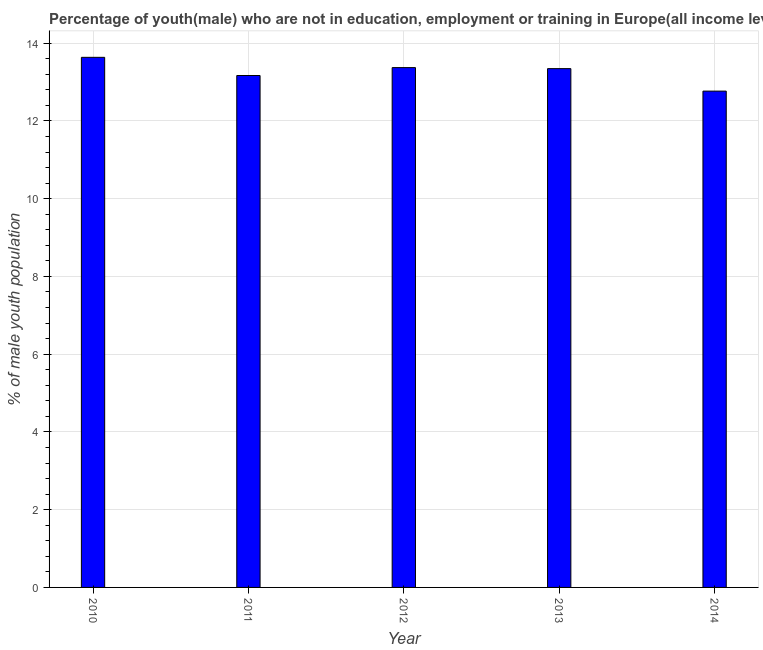Does the graph contain any zero values?
Offer a terse response. No. Does the graph contain grids?
Give a very brief answer. Yes. What is the title of the graph?
Provide a succinct answer. Percentage of youth(male) who are not in education, employment or training in Europe(all income levels). What is the label or title of the X-axis?
Provide a succinct answer. Year. What is the label or title of the Y-axis?
Offer a very short reply. % of male youth population. What is the unemployed male youth population in 2012?
Give a very brief answer. 13.37. Across all years, what is the maximum unemployed male youth population?
Your answer should be compact. 13.64. Across all years, what is the minimum unemployed male youth population?
Give a very brief answer. 12.77. In which year was the unemployed male youth population maximum?
Your answer should be very brief. 2010. In which year was the unemployed male youth population minimum?
Ensure brevity in your answer.  2014. What is the sum of the unemployed male youth population?
Your answer should be compact. 66.29. What is the difference between the unemployed male youth population in 2010 and 2011?
Your response must be concise. 0.47. What is the average unemployed male youth population per year?
Make the answer very short. 13.26. What is the median unemployed male youth population?
Ensure brevity in your answer.  13.35. Do a majority of the years between 2010 and 2013 (inclusive) have unemployed male youth population greater than 3.2 %?
Offer a very short reply. Yes. What is the ratio of the unemployed male youth population in 2010 to that in 2012?
Give a very brief answer. 1.02. What is the difference between the highest and the second highest unemployed male youth population?
Your response must be concise. 0.26. Is the sum of the unemployed male youth population in 2011 and 2014 greater than the maximum unemployed male youth population across all years?
Keep it short and to the point. Yes. What is the difference between the highest and the lowest unemployed male youth population?
Offer a very short reply. 0.87. In how many years, is the unemployed male youth population greater than the average unemployed male youth population taken over all years?
Ensure brevity in your answer.  3. Are all the bars in the graph horizontal?
Your answer should be very brief. No. How many years are there in the graph?
Your answer should be compact. 5. Are the values on the major ticks of Y-axis written in scientific E-notation?
Offer a very short reply. No. What is the % of male youth population of 2010?
Ensure brevity in your answer.  13.64. What is the % of male youth population of 2011?
Give a very brief answer. 13.17. What is the % of male youth population in 2012?
Offer a terse response. 13.37. What is the % of male youth population in 2013?
Your response must be concise. 13.35. What is the % of male youth population of 2014?
Your response must be concise. 12.77. What is the difference between the % of male youth population in 2010 and 2011?
Provide a succinct answer. 0.47. What is the difference between the % of male youth population in 2010 and 2012?
Your answer should be very brief. 0.26. What is the difference between the % of male youth population in 2010 and 2013?
Give a very brief answer. 0.29. What is the difference between the % of male youth population in 2010 and 2014?
Make the answer very short. 0.87. What is the difference between the % of male youth population in 2011 and 2012?
Your answer should be compact. -0.2. What is the difference between the % of male youth population in 2011 and 2013?
Give a very brief answer. -0.18. What is the difference between the % of male youth population in 2011 and 2014?
Offer a terse response. 0.4. What is the difference between the % of male youth population in 2012 and 2013?
Offer a very short reply. 0.03. What is the difference between the % of male youth population in 2012 and 2014?
Provide a short and direct response. 0.6. What is the difference between the % of male youth population in 2013 and 2014?
Offer a terse response. 0.58. What is the ratio of the % of male youth population in 2010 to that in 2011?
Provide a succinct answer. 1.04. What is the ratio of the % of male youth population in 2010 to that in 2014?
Your answer should be very brief. 1.07. What is the ratio of the % of male youth population in 2011 to that in 2013?
Your answer should be very brief. 0.99. What is the ratio of the % of male youth population in 2011 to that in 2014?
Ensure brevity in your answer.  1.03. What is the ratio of the % of male youth population in 2012 to that in 2014?
Your answer should be compact. 1.05. What is the ratio of the % of male youth population in 2013 to that in 2014?
Give a very brief answer. 1.04. 